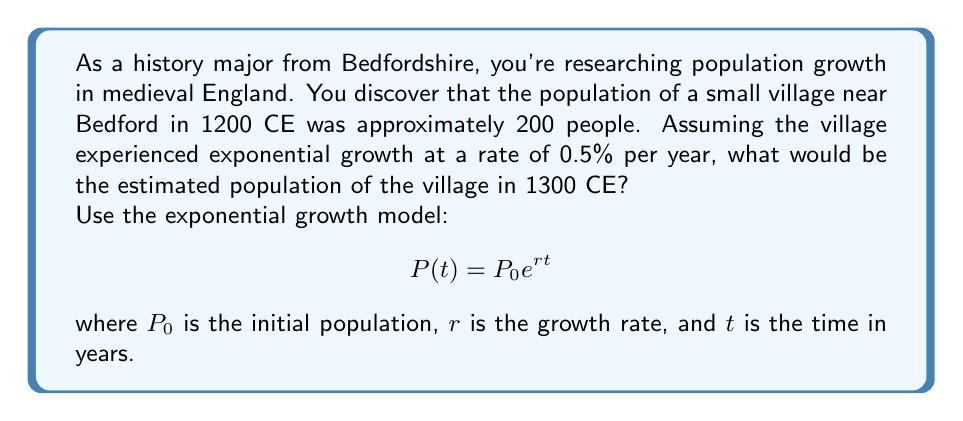Provide a solution to this math problem. To solve this problem, we'll use the exponential growth model:

$$P(t) = P_0e^{rt}$$

Given:
- Initial population, $P_0 = 200$
- Growth rate, $r = 0.5\% = 0.005$ (convert percentage to decimal)
- Time period, $t = 1300 - 1200 = 100$ years

Let's substitute these values into the equation:

$$P(100) = 200e^{0.005 \times 100}$$

Now, let's calculate step by step:

1) First, multiply the rate and time:
   $0.005 \times 100 = 0.5$

2) Our equation now looks like:
   $$P(100) = 200e^{0.5}$$

3) Calculate $e^{0.5}$:
   $e^{0.5} \approx 1.6487$

4) Multiply this by the initial population:
   $200 \times 1.6487 \approx 329.74$

5) Round to the nearest whole number, as we're dealing with people:
   $329.74 \approx 330$

Therefore, the estimated population of the village in 1300 CE would be approximately 330 people.
Answer: The estimated population of the village in 1300 CE would be approximately 330 people. 